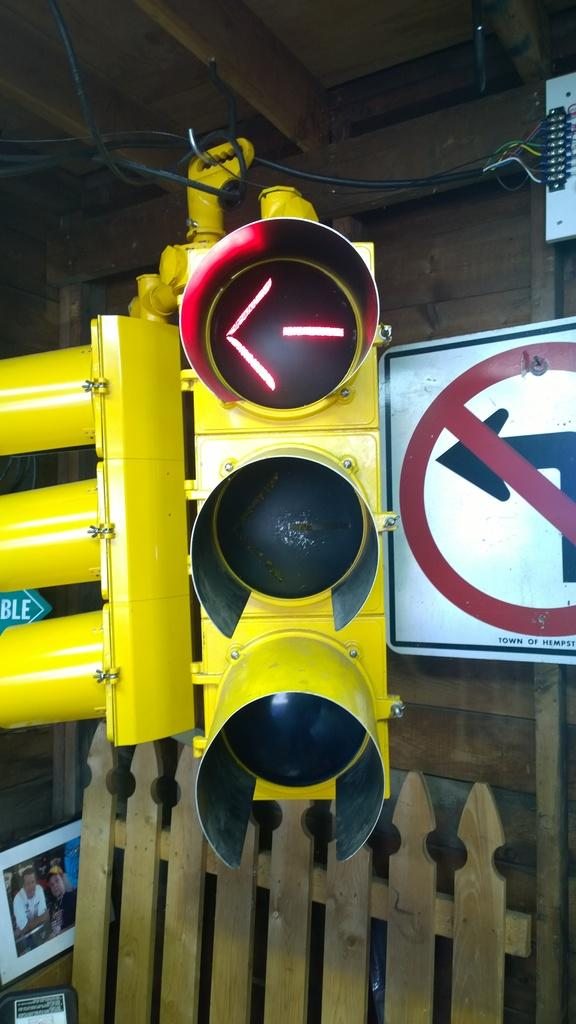What is the main object in the middle of the image? There is a traffic light in the middle of the image. What is located behind the traffic light? There is a sign board behind the traffic light. What type of fence is present in the image? There is a wooden fence in the image. Where is the wooden fence positioned in relation to the wall? The wooden fence is in front of a wall. What type of plastic alarm can be seen on the traffic light in the image? There is no plastic alarm present on the traffic light in the image. Who is the writer of the sign board in the image? There is no writer mentioned or visible in the image; we can only see the sign board itself. 